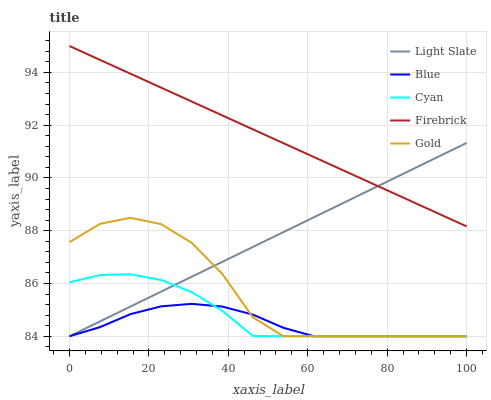Does Blue have the minimum area under the curve?
Answer yes or no. Yes. Does Firebrick have the maximum area under the curve?
Answer yes or no. Yes. Does Firebrick have the minimum area under the curve?
Answer yes or no. No. Does Blue have the maximum area under the curve?
Answer yes or no. No. Is Light Slate the smoothest?
Answer yes or no. Yes. Is Gold the roughest?
Answer yes or no. Yes. Is Blue the smoothest?
Answer yes or no. No. Is Blue the roughest?
Answer yes or no. No. Does Light Slate have the lowest value?
Answer yes or no. Yes. Does Firebrick have the lowest value?
Answer yes or no. No. Does Firebrick have the highest value?
Answer yes or no. Yes. Does Blue have the highest value?
Answer yes or no. No. Is Cyan less than Firebrick?
Answer yes or no. Yes. Is Firebrick greater than Gold?
Answer yes or no. Yes. Does Light Slate intersect Firebrick?
Answer yes or no. Yes. Is Light Slate less than Firebrick?
Answer yes or no. No. Is Light Slate greater than Firebrick?
Answer yes or no. No. Does Cyan intersect Firebrick?
Answer yes or no. No. 